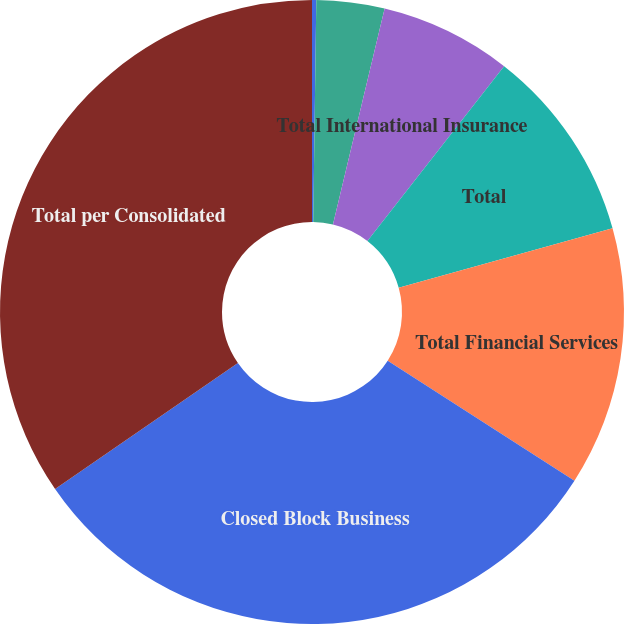Convert chart to OTSL. <chart><loc_0><loc_0><loc_500><loc_500><pie_chart><fcel>Individual Life and Annuities<fcel>International Insurance<fcel>Total International Insurance<fcel>Total<fcel>Total Financial Services<fcel>Closed Block Business<fcel>Total per Consolidated<nl><fcel>0.22%<fcel>3.52%<fcel>6.82%<fcel>10.12%<fcel>13.42%<fcel>31.31%<fcel>34.61%<nl></chart> 